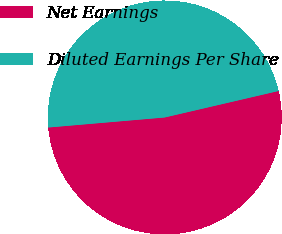Convert chart to OTSL. <chart><loc_0><loc_0><loc_500><loc_500><pie_chart><fcel>Net Earnings<fcel>Diluted Earnings Per Share<nl><fcel>52.27%<fcel>47.73%<nl></chart> 